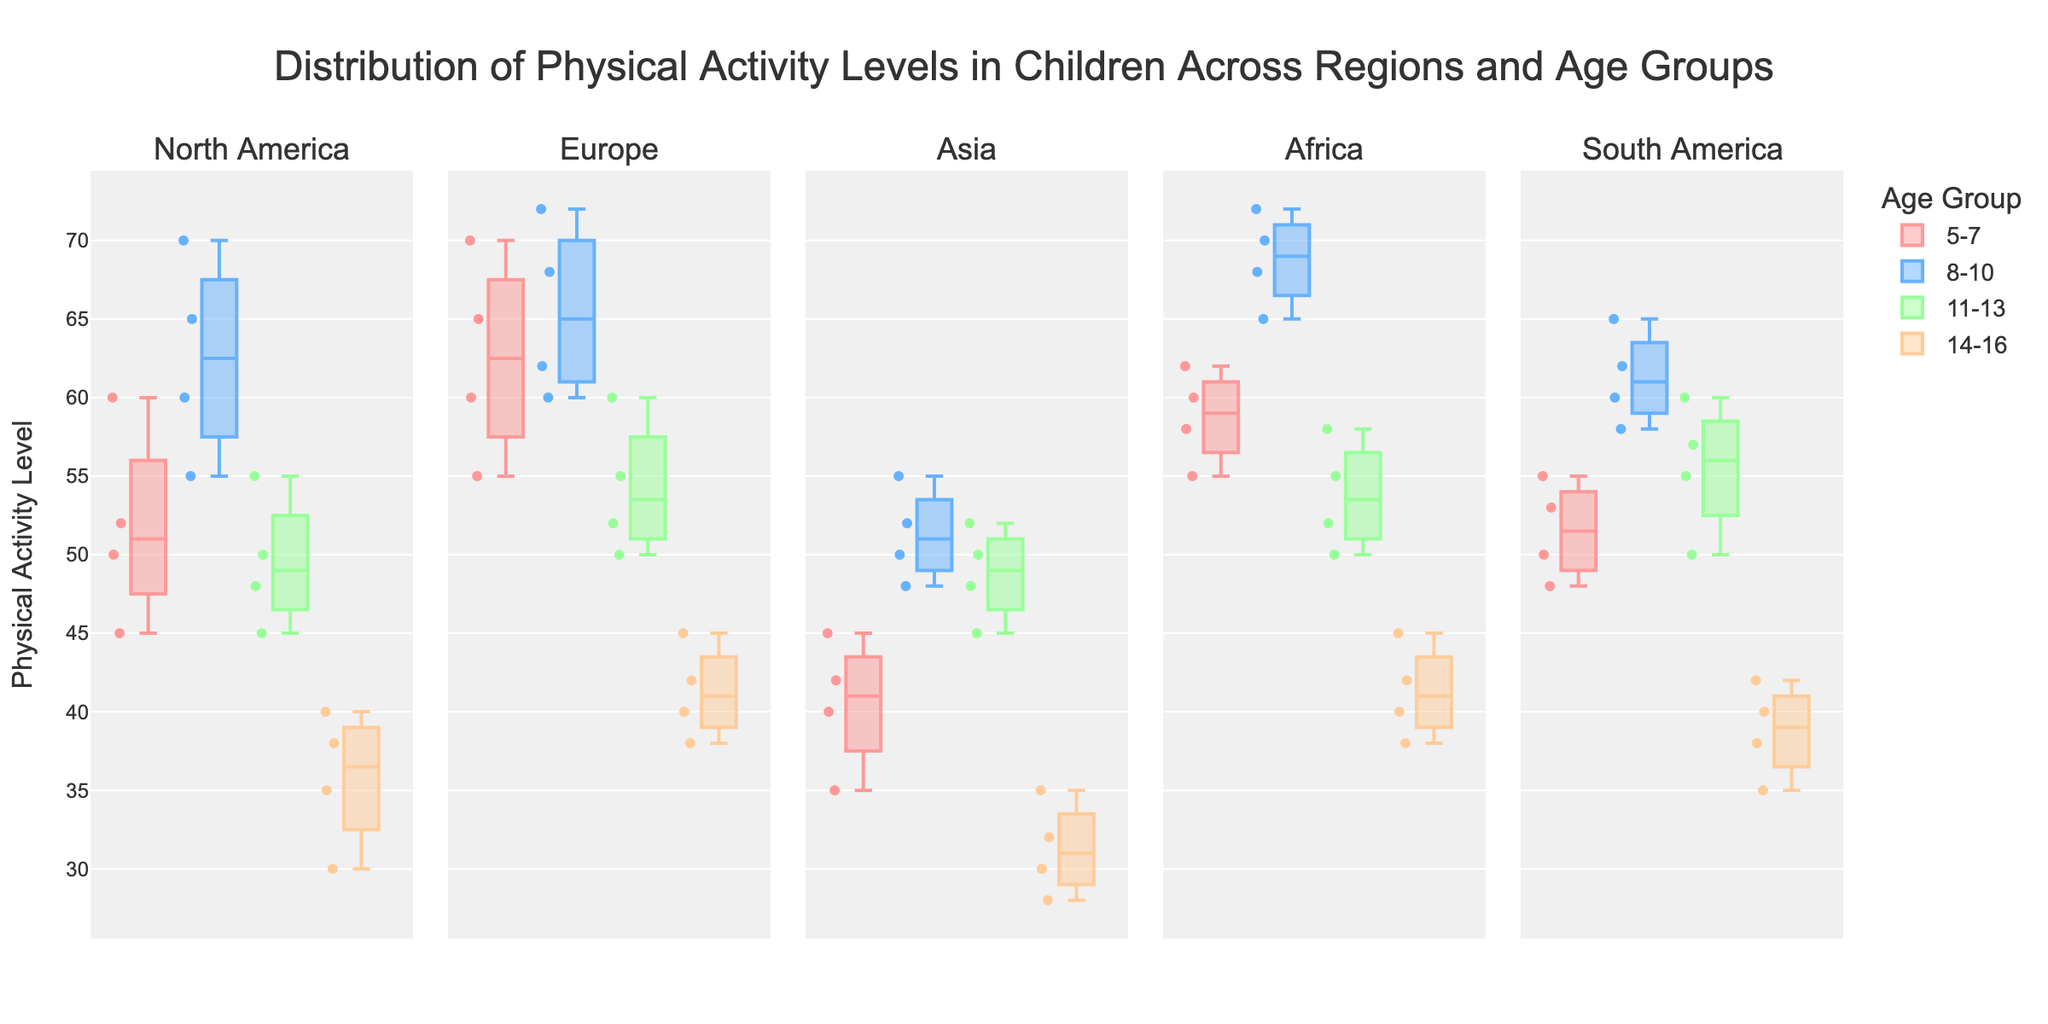What does the title of the figure indicate? The title reads "Distribution of Physical Activity Levels in Children Across Regions and Age Groups", which indicates that the figure shows how physical activity levels vary among children across different regions and age groups.
Answer: Distribution of Physical Activity Levels in Children Across Regions and Age Groups Which regions are included in the figure? The subplot titles indicate that the regions included are North America, Europe, Asia, Africa, and South America.
Answer: North America, Europe, Asia, Africa, and South America How does the physical activity level of 5-7 year-olds in North America compare to 8-10 year-olds? By comparing the box plots for the different age groups within North America, the 5-7 year-olds appear to have lower physical activity levels than the 8-10 year-olds based on the medians and distributions shown.
Answer: 5-7 year-olds have lower levels than 8-10 year-olds What are the possible physical activity levels for 14-16 year-olds in Asia according to the data? Observing the box plot for 14-16 year-olds in Asia, the physical activity levels range from about 28 to 35, as represented by the box’s quartiles and the whiskers.
Answer: 28 to 35 Which age group generally has the highest physical activity levels in Africa? By examining the box plots for all age groups in Africa, the 8-10 year-olds show the highest physical activity levels. This can be seen in the position of the median within the boxes and the range.
Answer: 8-10 year-olds Which age group shows the lowest physical activity levels in Europe? Focusing on the box plots for Europe, the 14-16 year-olds show the lowest physical activity levels with a lower median and smaller range compared to other age groups.
Answer: 14-16 year-olds What is the range of physical activity levels for 11-13 year-olds in South America? By looking at the box plot for 11-13 year-olds in South America, the range is approximately from 50 to 60, as indicated by the whiskers.
Answer: 50 to 60 Compare the physical activity levels of 5-7 year-olds between North America and Europe. Observing the box plots for 5-7 year-olds in both regions, Europe's children generally show higher physical activity levels compared to North America's, as indicated by the boxes’ positions and medians.
Answer: Europe is higher than North America Which region shows the broadest range of physical activity levels for 8-10 year-olds? Comparing the box plots for 8-10 year-olds across all regions, Europe shows the broadest range of activity levels, as indicated by the length of the whiskers from the minimum to the maximum values.
Answer: Europe Are there any age groups where all regions have similar ranges of physical activity levels? By comparing box plots across all regions for each age group, 14-16 year-olds show relatively similar ranges of physical activity levels as the medians and range of data points are more alike across different regions.
Answer: Yes, the 14-16 year-olds 